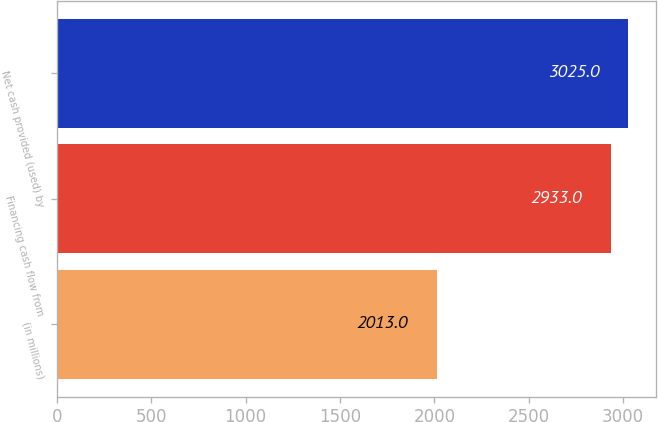<chart> <loc_0><loc_0><loc_500><loc_500><bar_chart><fcel>(in millions)<fcel>Financing cash flow from<fcel>Net cash provided (used) by<nl><fcel>2013<fcel>2933<fcel>3025<nl></chart> 